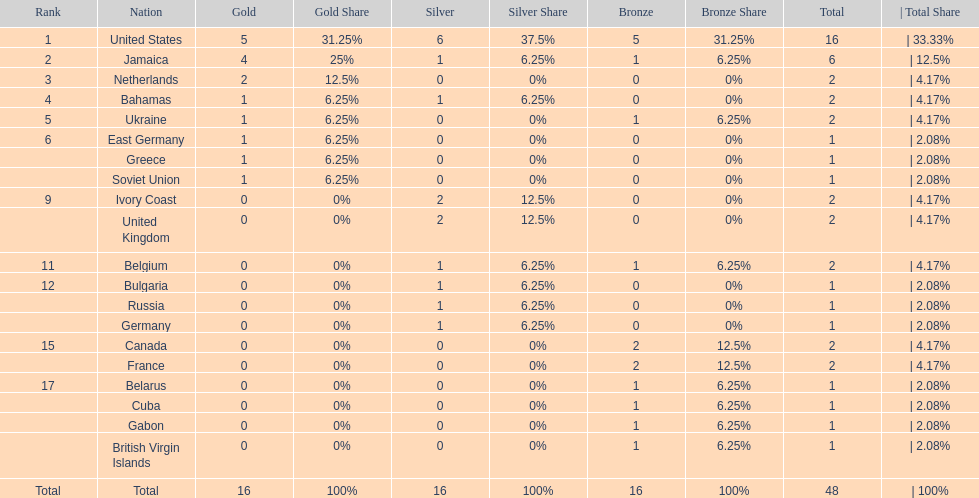After the united states, what country won the most gold medals. Jamaica. 